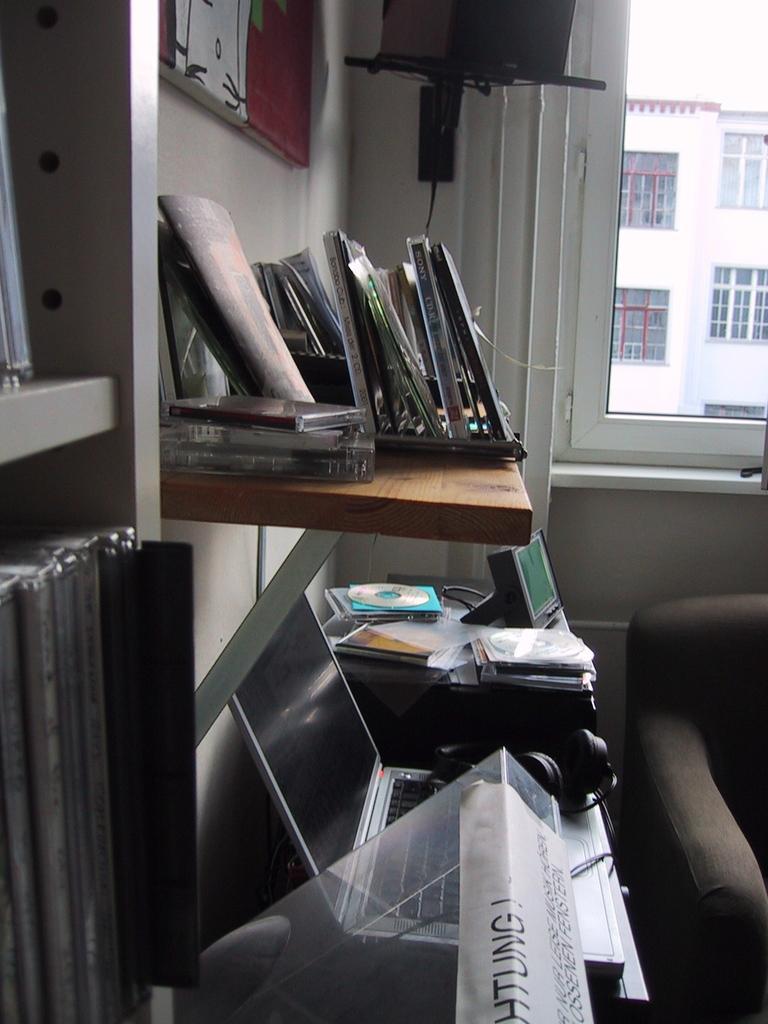Describe this image in one or two sentences. In the foreground of the image we can see a laptop, headphones, group of disks are placed on a table. to the right side of the image we can see a chair. On the left side of the image we can see group of books placed in a rack. In the center of the image we can see group of disks placed on self. In the background, we can see a speaker on a stand, photo frame on the wall, window and the sky. 